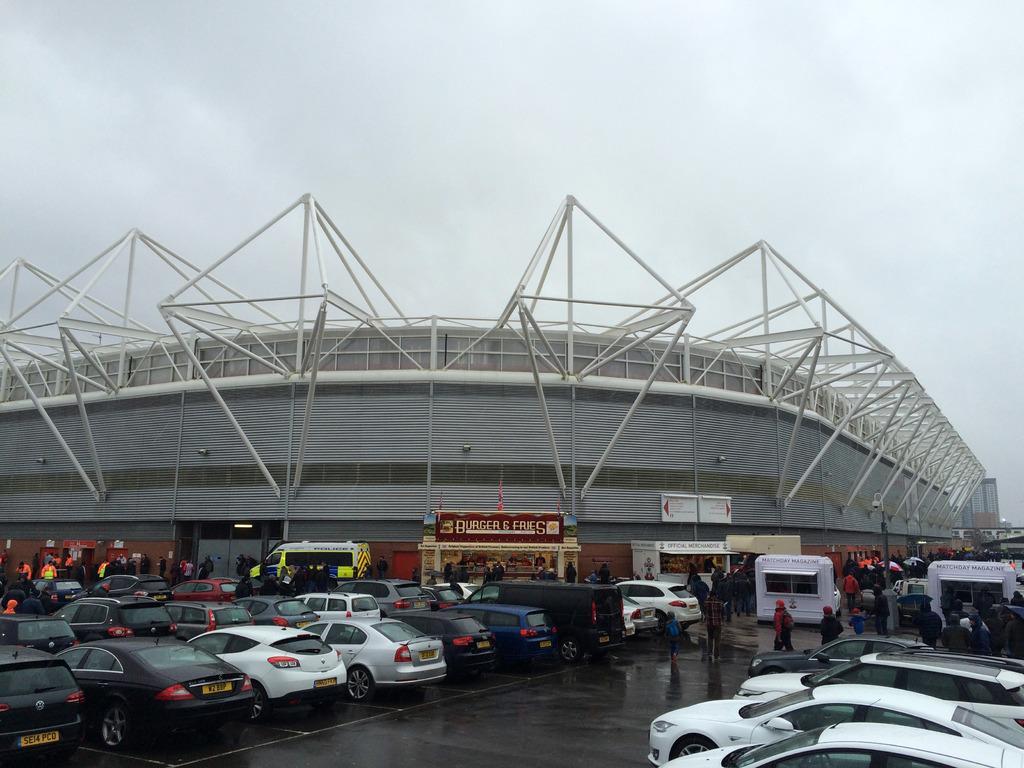In one or two sentences, can you explain what this image depicts? In this image I can see number of vehicles and number of people are standing near it. In the background I can see a building and on it I can see number of poles, few boards and on it I can see something is written. I can also see the sky in the background. 